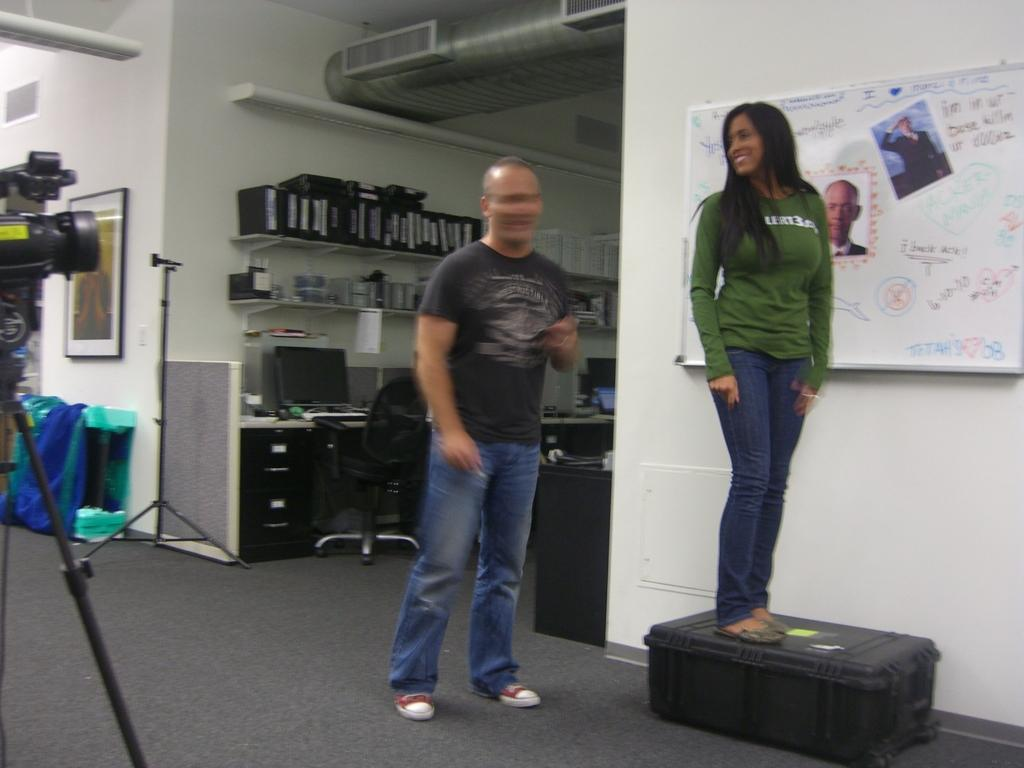How many people are in the image? There are two persons standing in the image. What can be seen in the background of the image? There is a wall, a frame, a chair, and other things visible in the background of the image. What is the purpose of the camera with a stand in the image? The camera with a stand is likely used for capturing images or videos. What is on the wall in the background of the image? There is a whiteboard on the wall. What letter is the person holding in the image? There is no letter present in the image. How does the sail affect the image? There is no sail present in the image. 